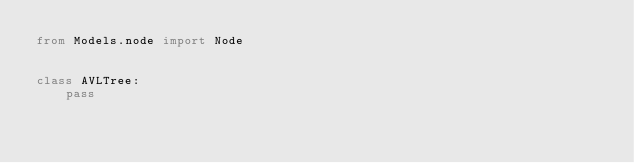<code> <loc_0><loc_0><loc_500><loc_500><_Python_>from Models.node import Node


class AVLTree:
    pass
</code> 